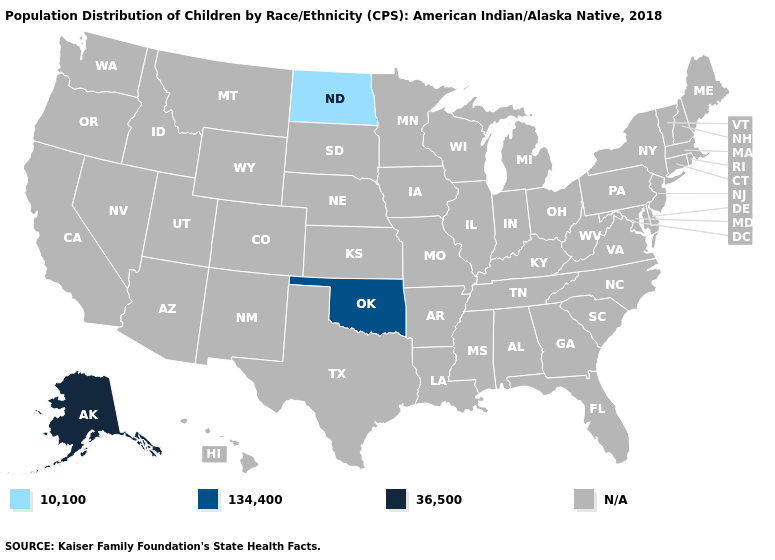Which states hav the highest value in the West?
Answer briefly. Alaska. Name the states that have a value in the range N/A?
Answer briefly. Alabama, Arizona, Arkansas, California, Colorado, Connecticut, Delaware, Florida, Georgia, Hawaii, Idaho, Illinois, Indiana, Iowa, Kansas, Kentucky, Louisiana, Maine, Maryland, Massachusetts, Michigan, Minnesota, Mississippi, Missouri, Montana, Nebraska, Nevada, New Hampshire, New Jersey, New Mexico, New York, North Carolina, Ohio, Oregon, Pennsylvania, Rhode Island, South Carolina, South Dakota, Tennessee, Texas, Utah, Vermont, Virginia, Washington, West Virginia, Wisconsin, Wyoming. What is the value of Massachusetts?
Give a very brief answer. N/A. Does the map have missing data?
Keep it brief. Yes. What is the highest value in the MidWest ?
Answer briefly. 10,100. What is the lowest value in the USA?
Keep it brief. 10,100. Which states have the lowest value in the USA?
Be succinct. North Dakota. Name the states that have a value in the range 134,400?
Quick response, please. Oklahoma. Name the states that have a value in the range 10,100?
Answer briefly. North Dakota. What is the highest value in the MidWest ?
Keep it brief. 10,100. Name the states that have a value in the range 134,400?
Short answer required. Oklahoma. What is the value of Ohio?
Be succinct. N/A. Name the states that have a value in the range 10,100?
Concise answer only. North Dakota. 